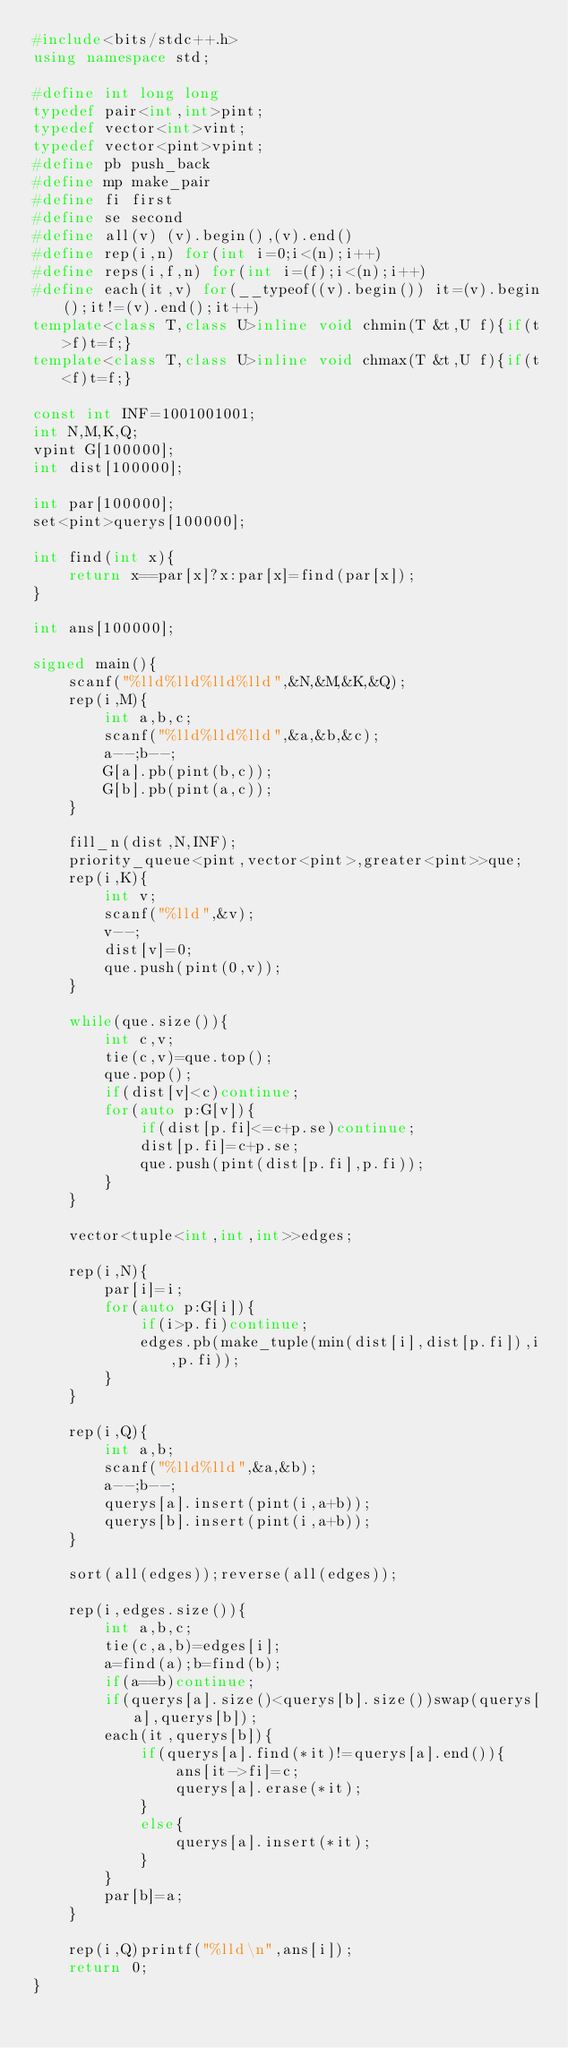Convert code to text. <code><loc_0><loc_0><loc_500><loc_500><_C++_>#include<bits/stdc++.h>
using namespace std;

#define int long long
typedef pair<int,int>pint;
typedef vector<int>vint;
typedef vector<pint>vpint;
#define pb push_back
#define mp make_pair
#define fi first
#define se second
#define all(v) (v).begin(),(v).end()
#define rep(i,n) for(int i=0;i<(n);i++)
#define reps(i,f,n) for(int i=(f);i<(n);i++)
#define each(it,v) for(__typeof((v).begin()) it=(v).begin();it!=(v).end();it++)
template<class T,class U>inline void chmin(T &t,U f){if(t>f)t=f;}
template<class T,class U>inline void chmax(T &t,U f){if(t<f)t=f;}

const int INF=1001001001;
int N,M,K,Q;
vpint G[100000];
int dist[100000];

int par[100000];
set<pint>querys[100000];

int find(int x){
    return x==par[x]?x:par[x]=find(par[x]);
}

int ans[100000];

signed main(){
    scanf("%lld%lld%lld%lld",&N,&M,&K,&Q);
    rep(i,M){
        int a,b,c;
        scanf("%lld%lld%lld",&a,&b,&c);
        a--;b--;
        G[a].pb(pint(b,c));
        G[b].pb(pint(a,c));
    }

    fill_n(dist,N,INF);
    priority_queue<pint,vector<pint>,greater<pint>>que;
    rep(i,K){
        int v;
        scanf("%lld",&v);
        v--;
        dist[v]=0;
        que.push(pint(0,v));
    }

    while(que.size()){
        int c,v;
        tie(c,v)=que.top();
        que.pop();
        if(dist[v]<c)continue;
        for(auto p:G[v]){
            if(dist[p.fi]<=c+p.se)continue;
            dist[p.fi]=c+p.se;
            que.push(pint(dist[p.fi],p.fi));
        }
    }

    vector<tuple<int,int,int>>edges;

    rep(i,N){
        par[i]=i;
        for(auto p:G[i]){
            if(i>p.fi)continue;
            edges.pb(make_tuple(min(dist[i],dist[p.fi]),i,p.fi));
        }
    }

    rep(i,Q){
        int a,b;
        scanf("%lld%lld",&a,&b);
        a--;b--;
        querys[a].insert(pint(i,a+b));
        querys[b].insert(pint(i,a+b));
    }

    sort(all(edges));reverse(all(edges));

    rep(i,edges.size()){
        int a,b,c;
        tie(c,a,b)=edges[i];
        a=find(a);b=find(b);
        if(a==b)continue;
        if(querys[a].size()<querys[b].size())swap(querys[a],querys[b]);
        each(it,querys[b]){
            if(querys[a].find(*it)!=querys[a].end()){
                ans[it->fi]=c;
                querys[a].erase(*it);
            }
            else{
                querys[a].insert(*it);
            }
        }
        par[b]=a;
    }

    rep(i,Q)printf("%lld\n",ans[i]);
    return 0;
}</code> 